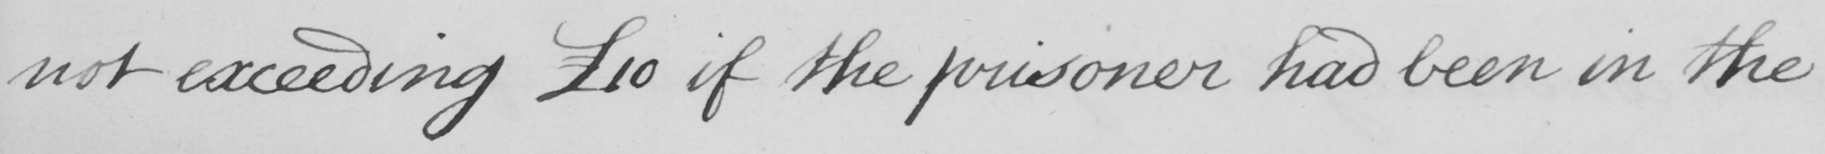Please provide the text content of this handwritten line. not exceeding £10 if the prisoner had been in the 